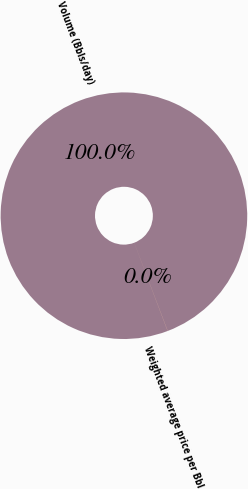Convert chart to OTSL. <chart><loc_0><loc_0><loc_500><loc_500><pie_chart><fcel>Volume (Bbls/day)<fcel>Weighted average price per Bbl<nl><fcel>99.99%<fcel>0.01%<nl></chart> 